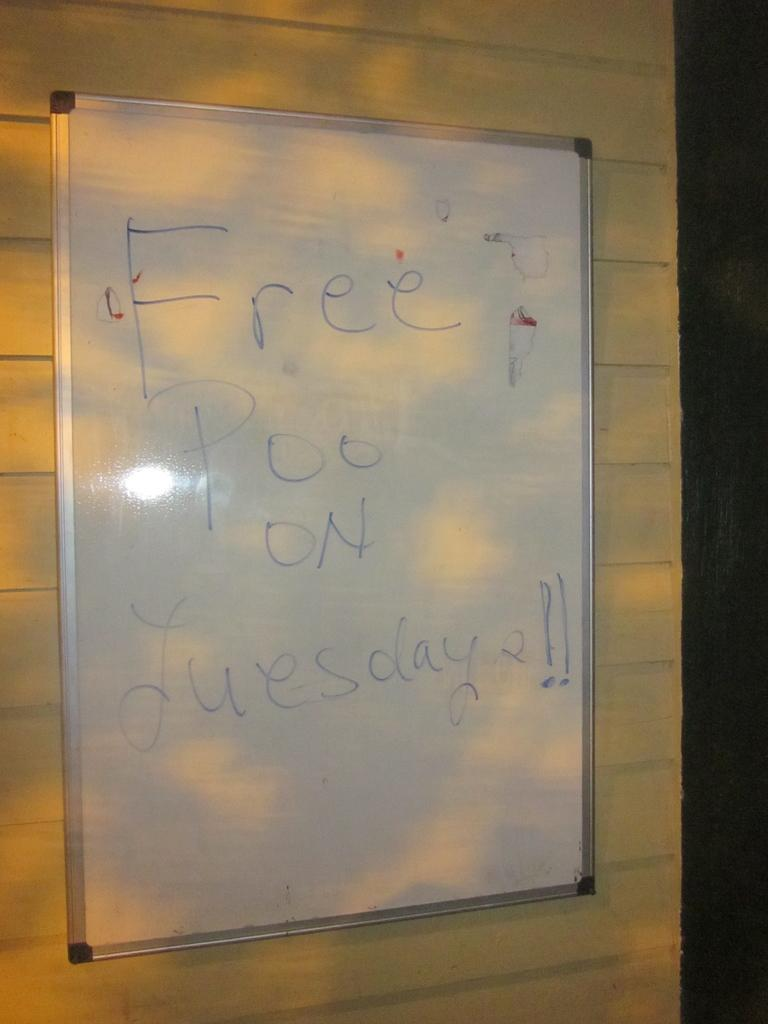<image>
Create a compact narrative representing the image presented. A whiteboard on a wall that says Free Poo on Tuesday. 